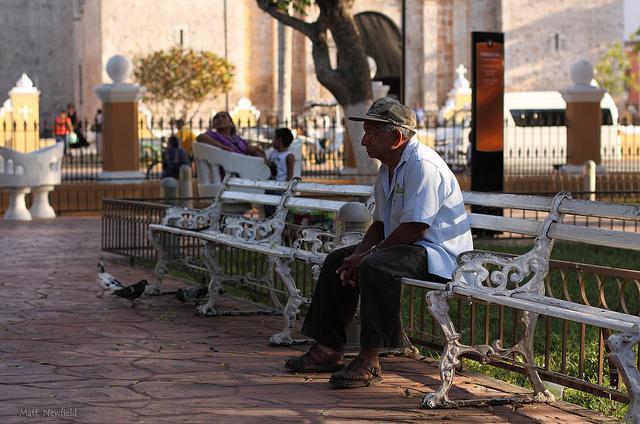How many bears are there?
Give a very brief answer. 0. 